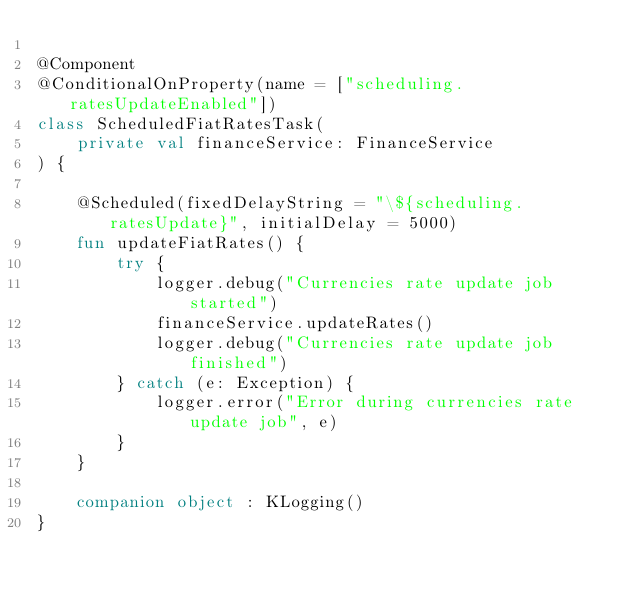Convert code to text. <code><loc_0><loc_0><loc_500><loc_500><_Kotlin_>
@Component
@ConditionalOnProperty(name = ["scheduling.ratesUpdateEnabled"])
class ScheduledFiatRatesTask(
    private val financeService: FinanceService
) {

    @Scheduled(fixedDelayString = "\${scheduling.ratesUpdate}", initialDelay = 5000)
    fun updateFiatRates() {
        try {
            logger.debug("Currencies rate update job started")
            financeService.updateRates()
            logger.debug("Currencies rate update job finished")
        } catch (e: Exception) {
            logger.error("Error during currencies rate update job", e)
        }
    }

    companion object : KLogging()
}
</code> 